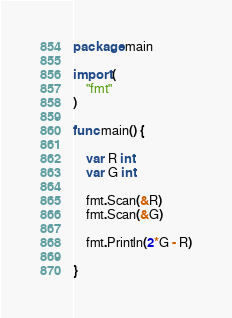Convert code to text. <code><loc_0><loc_0><loc_500><loc_500><_Go_>package main

import (
	"fmt"
)

func main() {

	var R int
	var G int 

	fmt.Scan(&R)
	fmt.Scan(&G)

	fmt.Println(2*G - R)

}
</code> 